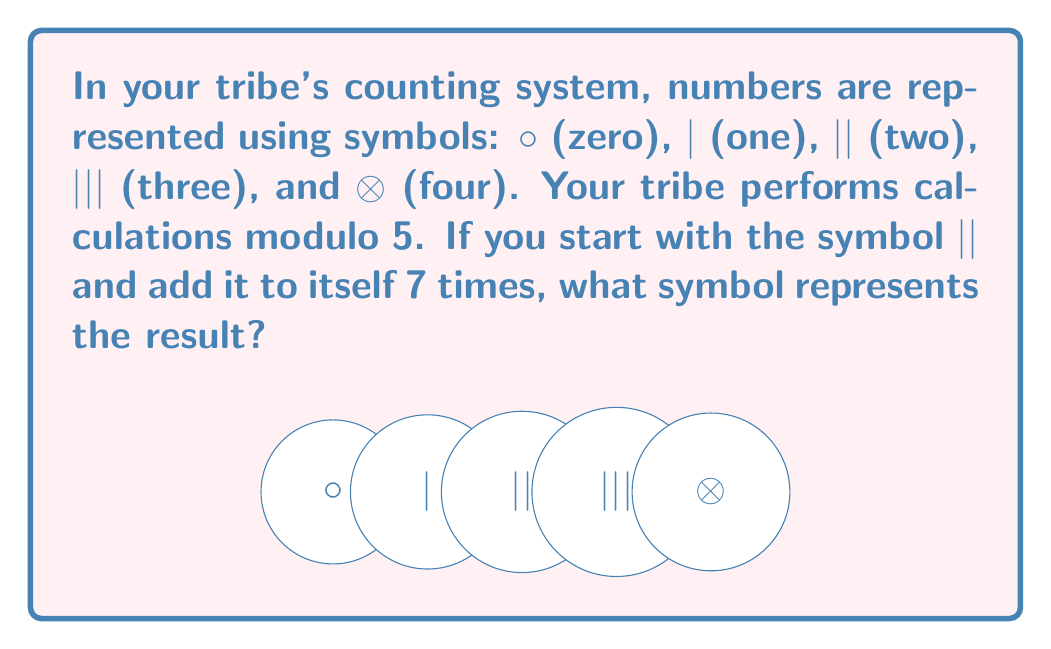What is the answer to this math problem? Let's approach this step-by-step:

1) In modular arithmetic with modulus 5, we are working in the ring $\mathbb{Z}_5$.

2) The symbol || represents 2 in this system.

3) We need to calculate $2 + 2 + 2 + 2 + 2 + 2 + 2 + 2$ (8 times 2).

4) In regular arithmetic, this would be $2 \times 8 = 16$.

5) However, in modulo 5 arithmetic, we need to find the remainder when 16 is divided by 5.

6) We can express this mathematically as:

   $16 \equiv x \pmod{5}$

7) To solve this, we divide 16 by 5:
   
   $16 = 3 \times 5 + 1$

8) Therefore, $16 \equiv 1 \pmod{5}$

9) In the tribal counting system, 1 is represented by the symbol |.

Thus, after adding || to itself 7 times, the result in modulo 5 arithmetic is represented by the symbol |.
Answer: | 